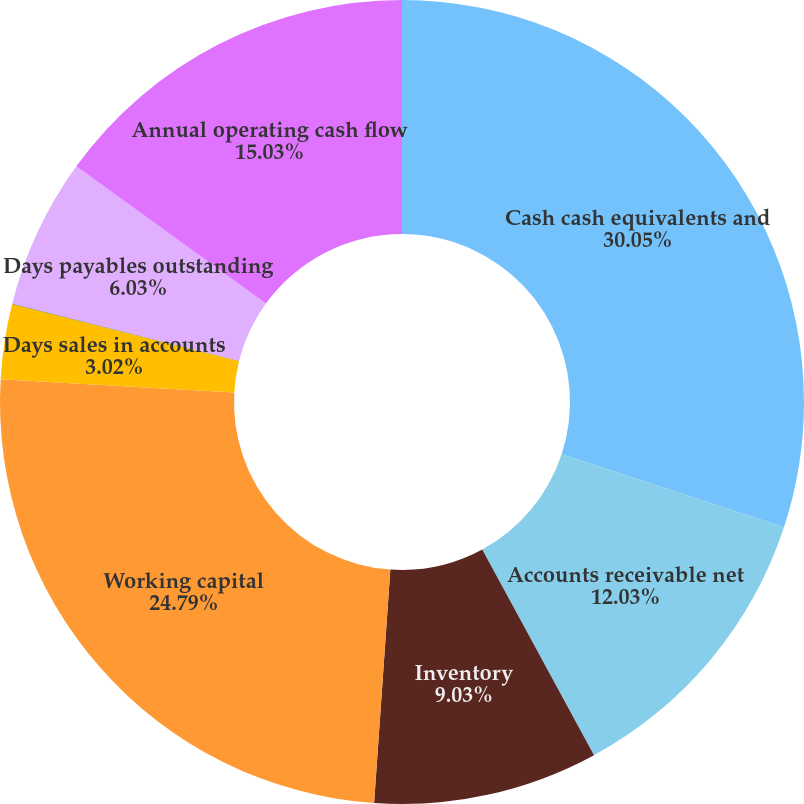<chart> <loc_0><loc_0><loc_500><loc_500><pie_chart><fcel>Cash cash equivalents and<fcel>Accounts receivable net<fcel>Inventory<fcel>Working capital<fcel>Days sales in accounts<fcel>Days of supply in inventory<fcel>Days payables outstanding<fcel>Annual operating cash flow<nl><fcel>30.04%<fcel>12.03%<fcel>9.03%<fcel>24.79%<fcel>3.02%<fcel>0.02%<fcel>6.03%<fcel>15.03%<nl></chart> 